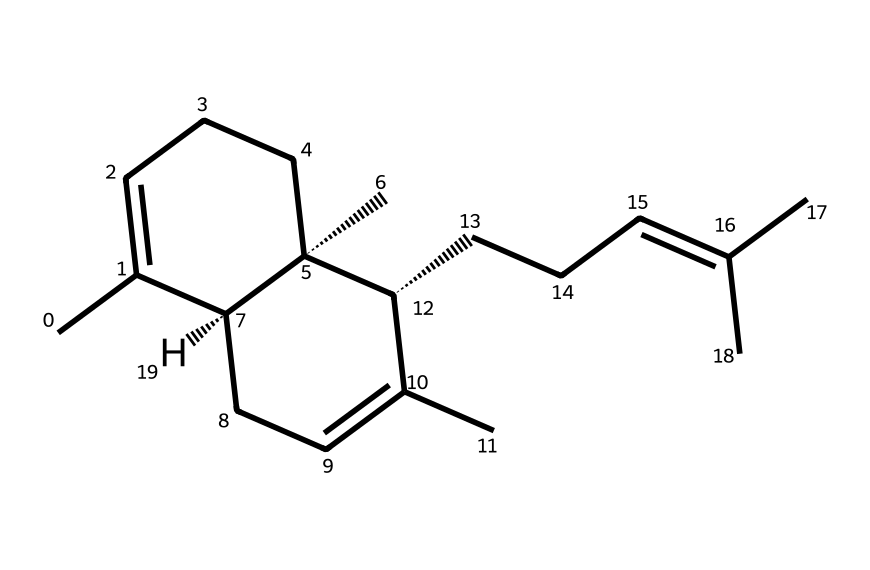What is the molecular formula of beta-caryophyllene? To determine the molecular formula, count the number of carbon (C), hydrogen (H), and any other atoms in the structure. In this case, the structure has 15 carbon atoms and 24 hydrogen atoms. Thus, the molecular formula is C15H24.
Answer: C15H24 How many rings are present in beta-caryophyllene? By analyzing the structure, we can identify that there are two distinct cyclic structures, making it a bicyclic compound. One ring is cyclohexane, and the second is also cyclohexane, forming a bicyclic structure.
Answer: 2 rings Does beta-caryophyllene have any double bonds? Observing the structure, there are two double bonds in the molecule. These can be identified in the cyclic portions where one carbon is double-bonded to another carbon.
Answer: Yes What is the role of beta-caryophyllene in vegan cooking? While it is not a primary ingredient, beta-caryophyllene contributes to the flavor and aroma profile of certain herbs and spices used in vegan cooking. Additionally, it may offer health benefits due to its potential anti-inflammatory properties.
Answer: Flavor and aroma How many chiral centers does beta-caryophyllene possess? By examining the structure, we identify two stereocenters (chiral centers) where carbon atoms are bonded to four different substituents, making it a chiral compound.
Answer: 2 chiral centers What type of compound is beta-caryophyllene classified as? Given its structure and properties, beta-caryophyllene is a terpene, specifically a sesquiterpene, which is defined by its composition of three isoprene units.
Answer: Terpene What potential health benefit does beta-caryophyllene exhibit? One of the key potential health benefits of beta-caryophyllene is its role in modulating inflammation, aligning with its observed properties in various studies.
Answer: Anti-inflammatory 